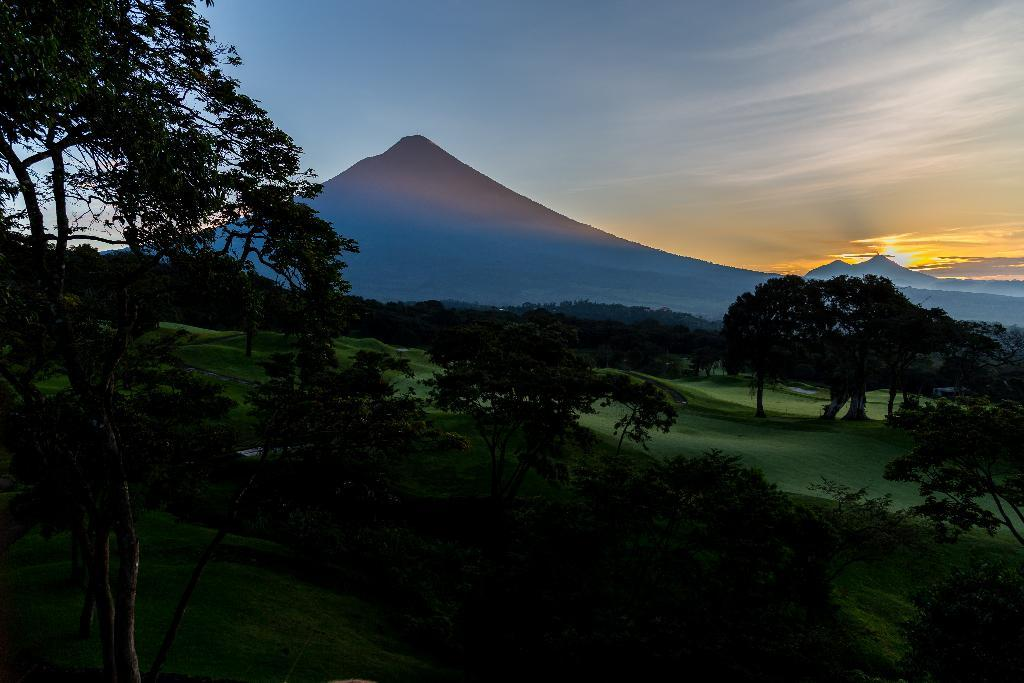What types of vegetation can be seen at the bottom of the image? There are trees, plants, and grass at the bottom of the image. What is the ground covered with at the bottom of the image? The ground is covered with grass at the bottom of the image. What can be seen in the background of the image? There are trees, grass, and mountains in the background of the image. What is visible in the sky in the image? There are clouds and the sun visible in the sky. What type of shirt is hanging on the wire in the image? There is no shirt or wire present in the image. What kind of test is being conducted in the image? There is no test or testing activity depicted in the image. 